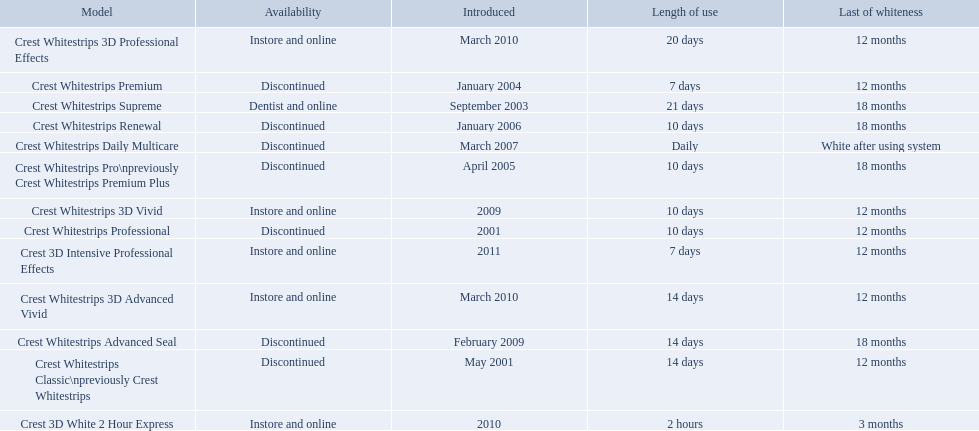Which of these products are discontinued? Crest Whitestrips Classic\npreviously Crest Whitestrips, Crest Whitestrips Professional, Crest Whitestrips Premium, Crest Whitestrips Pro\npreviously Crest Whitestrips Premium Plus, Crest Whitestrips Renewal, Crest Whitestrips Daily Multicare, Crest Whitestrips Advanced Seal. Which of these products have a 14 day length of use? Crest Whitestrips Classic\npreviously Crest Whitestrips, Crest Whitestrips Advanced Seal. Which of these products was introduced in 2009? Crest Whitestrips Advanced Seal. 